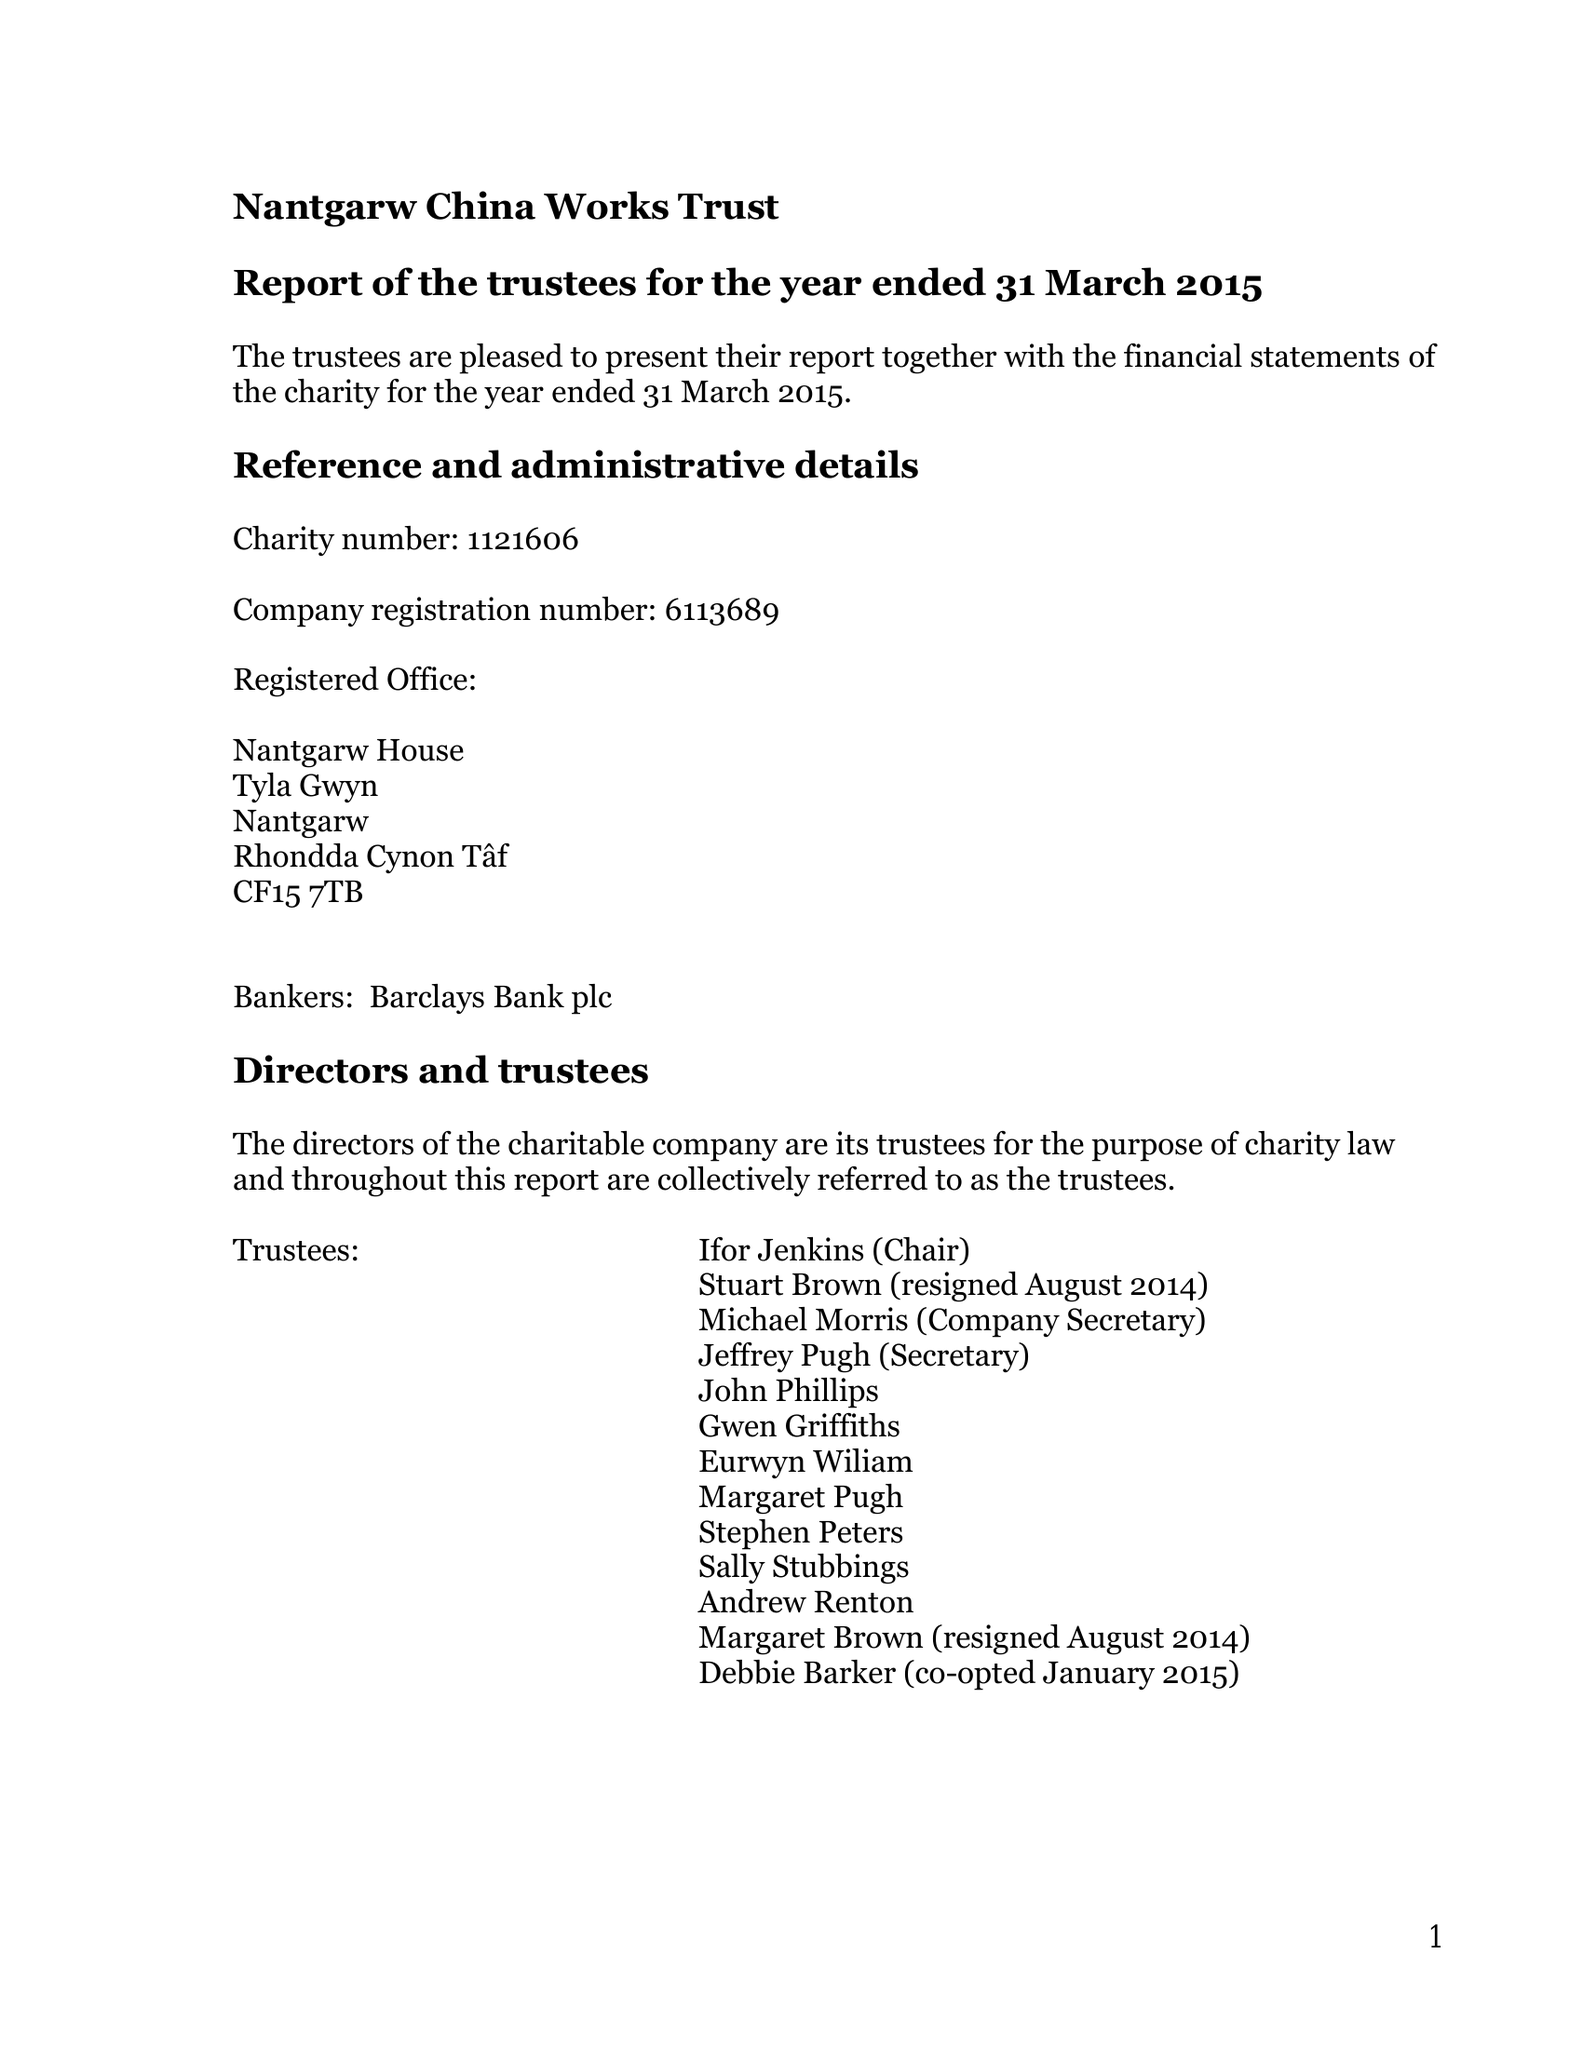What is the value for the spending_annually_in_british_pounds?
Answer the question using a single word or phrase. 30644.00 